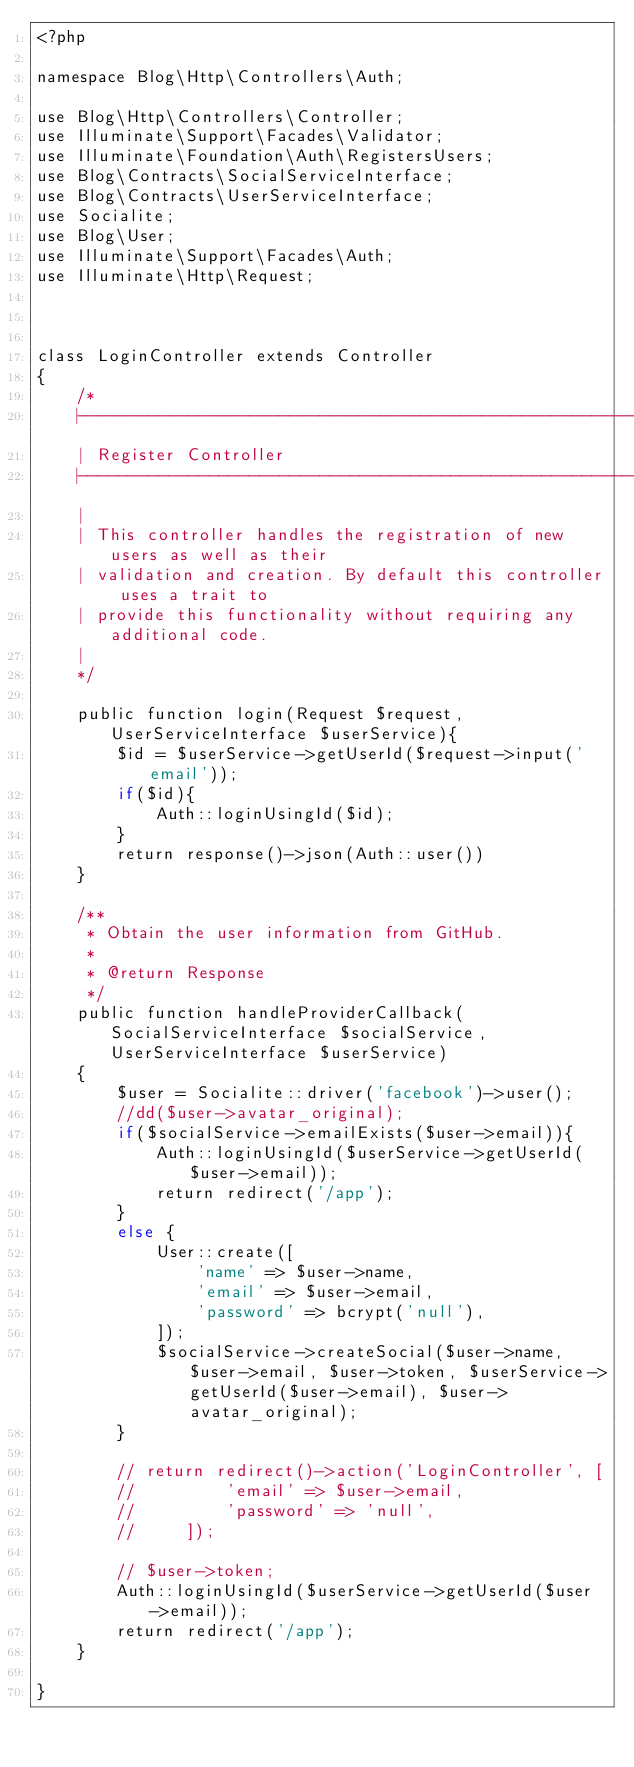<code> <loc_0><loc_0><loc_500><loc_500><_PHP_><?php

namespace Blog\Http\Controllers\Auth;

use Blog\Http\Controllers\Controller;
use Illuminate\Support\Facades\Validator;
use Illuminate\Foundation\Auth\RegistersUsers;
use Blog\Contracts\SocialServiceInterface;
use Blog\Contracts\UserServiceInterface;
use Socialite;
use Blog\User;
use Illuminate\Support\Facades\Auth;
use Illuminate\Http\Request;



class LoginController extends Controller
{
    /*
    |--------------------------------------------------------------------------
    | Register Controller
    |--------------------------------------------------------------------------
    |
    | This controller handles the registration of new users as well as their
    | validation and creation. By default this controller uses a trait to
    | provide this functionality without requiring any additional code.
    |
    */
    
    public function login(Request $request, UserServiceInterface $userService){
        $id = $userService->getUserId($request->input('email'));
        if($id){
            Auth::loginUsingId($id);
        }
        return response()->json(Auth::user())
    }

    /**
     * Obtain the user information from GitHub.
     *
     * @return Response
     */
    public function handleProviderCallback(SocialServiceInterface $socialService, UserServiceInterface $userService)
    {
        $user = Socialite::driver('facebook')->user();
        //dd($user->avatar_original);
        if($socialService->emailExists($user->email)){
            Auth::loginUsingId($userService->getUserId($user->email));
            return redirect('/app');
        }
        else {
            User::create([
                'name' => $user->name,  
                'email' => $user->email,
                'password' => bcrypt('null'),
            ]);
            $socialService->createSocial($user->name, $user->email, $user->token, $userService->getUserId($user->email), $user->avatar_original);
        }

        // return redirect()->action('LoginController', [
        //         'email' => $user->email,
        //         'password' => 'null', 
        //     ]);

        // $user->token;
        Auth::loginUsingId($userService->getUserId($user->email));
        return redirect('/app');
    }

}
</code> 